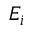<formula> <loc_0><loc_0><loc_500><loc_500>E _ { i }</formula> 